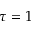<formula> <loc_0><loc_0><loc_500><loc_500>\tau = 1</formula> 